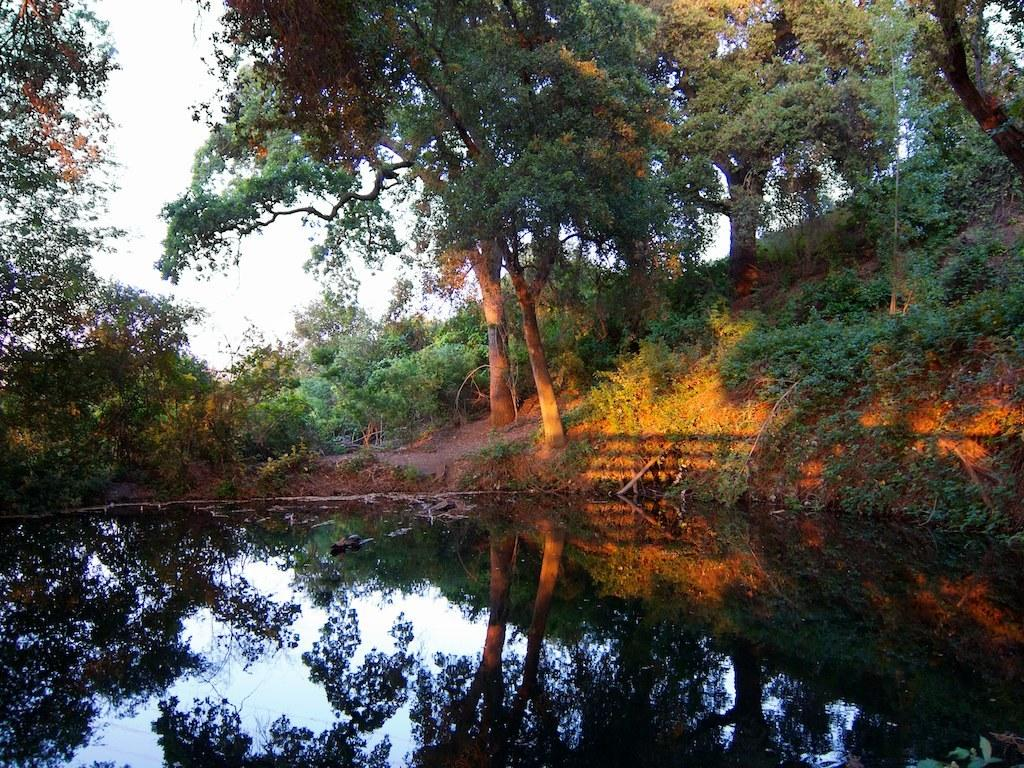What is present at the bottom of the image? There is water at the bottom side of the image. What can be seen in the center of the image? There is greenery in the center of the image. What type of business is being conducted in the image? There is no indication of a business in the image; it primarily features water and greenery. What invention is depicted in the image? There is no invention depicted in the image; it primarily features water and greenery. 